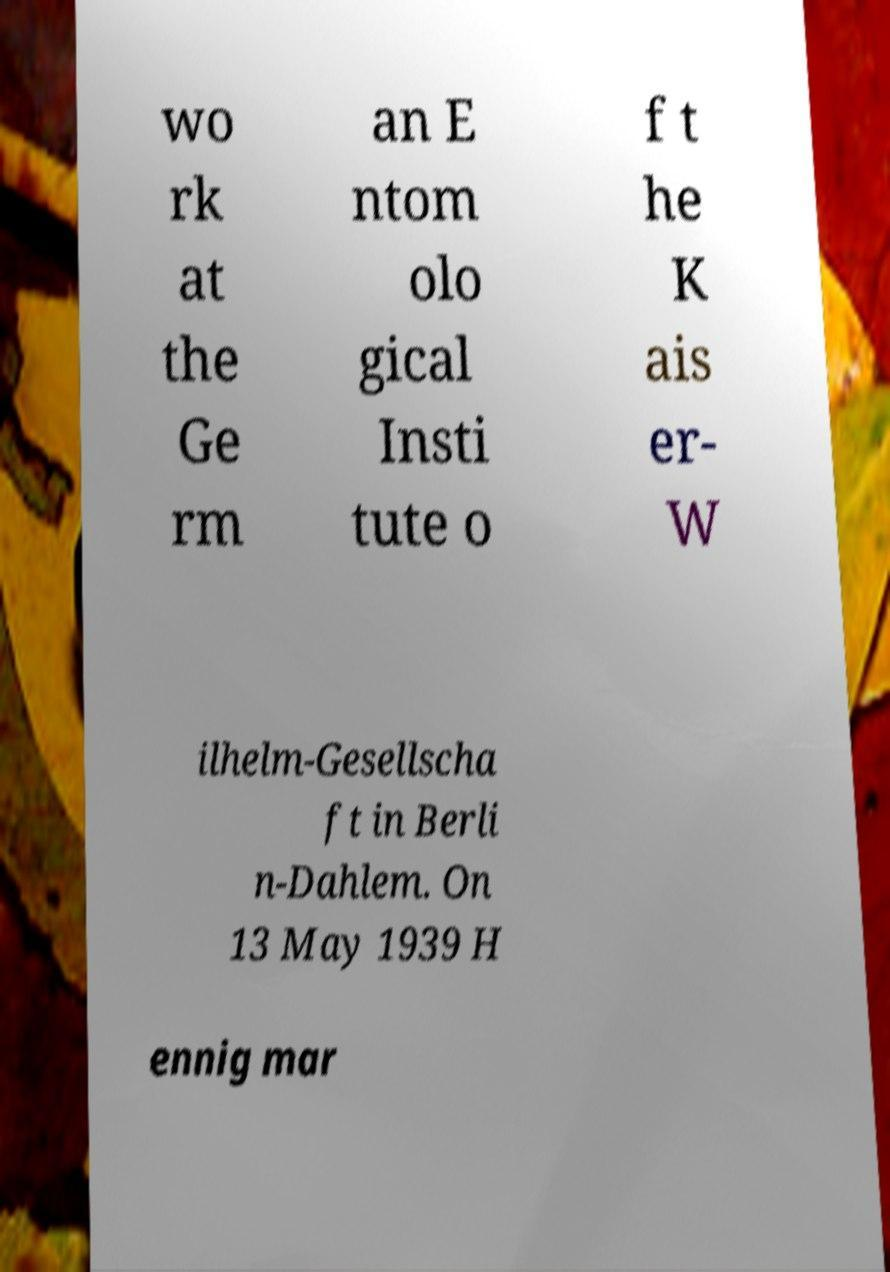Could you extract and type out the text from this image? wo rk at the Ge rm an E ntom olo gical Insti tute o f t he K ais er- W ilhelm-Gesellscha ft in Berli n-Dahlem. On 13 May 1939 H ennig mar 